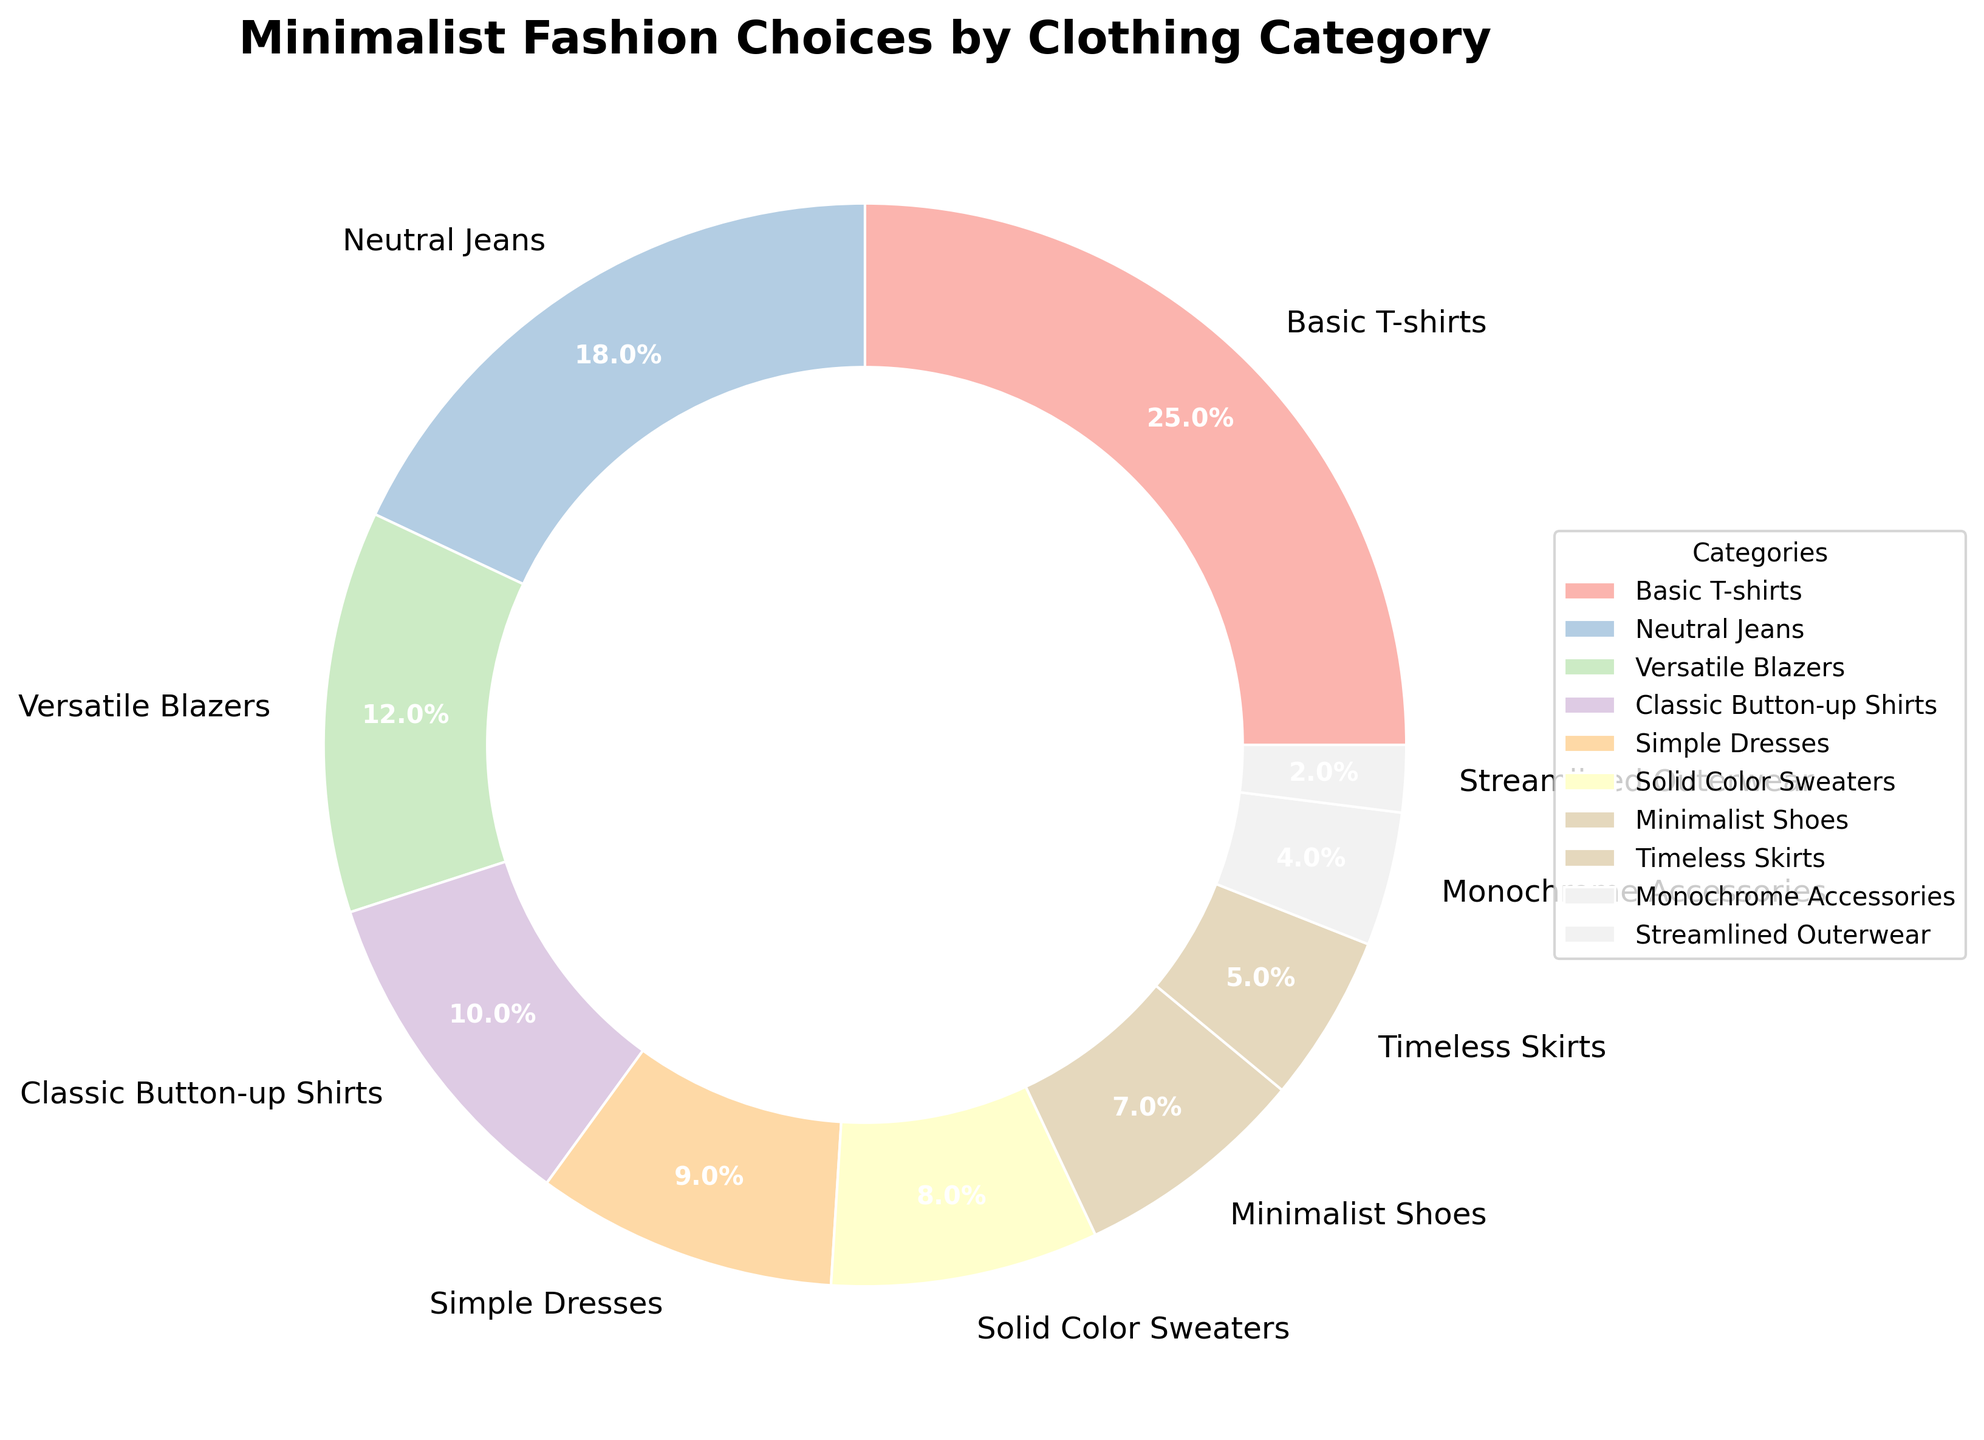What is the percentage of the most popular clothing category? The most popular clothing category is Basic T-shirts. By looking at the pie chart, we can see that Basic T-shirts have the highest percentage.
Answer: 25% Which category has a higher percentage: Versatile Blazers or Simple Dresses? Versatile Blazers have a percentage of 12%, and Simple Dresses have a percentage of 9%. By comparing these two values, Versatile Blazers have a higher percentage.
Answer: Versatile Blazers What is the combined percentage of Neutral Jeans and Classic Button-up Shirts? Neutral Jeans account for 18% and Classic Button-up Shirts account for 10%. Adding these percentages together, 18% + 10% = 28%.
Answer: 28% How many categories have a percentage of less than 10%? From the pie chart, categories with percentages less than 10% are Simple Dresses (9%), Solid Color Sweaters (8%), Minimalist Shoes (7%), Timeless Skirts (5%), Monochrome Accessories (4%), and Streamlined Outerwear (2%). Counting these categories, we find that there are 6 such categories.
Answer: 6 Which category has the smallest percentage? The category with the smallest percentage is Streamlined Outerwear. By examining the pie chart, we can see that Streamlined Outerwear has the smallest slice, which is 2%.
Answer: Streamlined Outerwear What is the visual attribute used to distinguish different categories in the pie chart? Different categories in the pie chart are distinguished by using varying colors for each category segment. Each segment has a unique color.
Answer: Colors Are Basic T-shirts more popular than Neutral Jeans? Basic T-shirts have a percentage of 25%, whereas Neutral Jeans have a percentage of 18%. Since 25% is greater than 18%, Basic T-shirts are more popular than Neutral Jeans.
Answer: Yes What is the combined percentage of Minimalist Shoes, Timeless Skirts, and Monochrome Accessories? Minimalist Shoes have a percentage of 7%, Timeless Skirts have 5%, and Monochrome Accessories have 4%. Adding these percentages together, 7% + 5% + 4% = 16%.
Answer: 16% Which has a larger percentage: Solid Color Sweaters or Monochrome Accessories? Solid Color Sweaters have a percentage of 8%, while Monochrome Accessories have a percentage of 4%. By comparing these values, Solid Color Sweaters have a larger percentage.
Answer: Solid Color Sweaters What is the difference in percentage between the largest and smallest categories? The largest category is Basic T-shirts with 25%, and the smallest category is Streamlined Outerwear with 2%. The difference is 25% - 2% = 23%.
Answer: 23% 